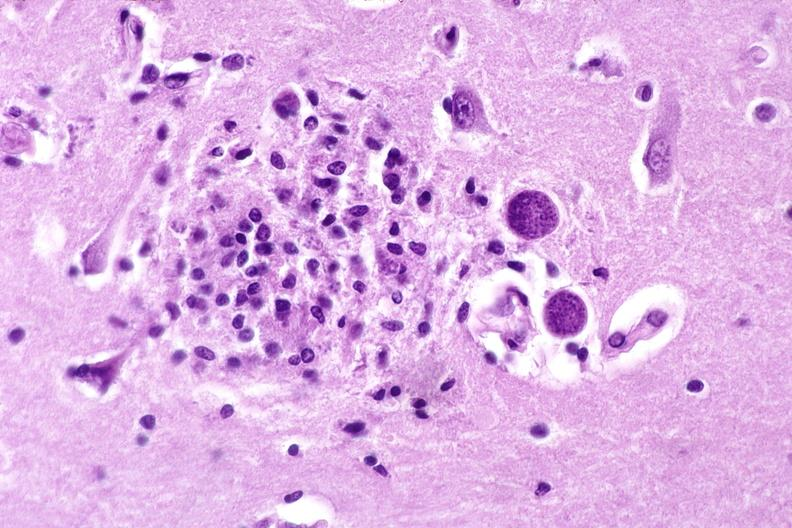what does this image show?
Answer the question using a single word or phrase. Brain 